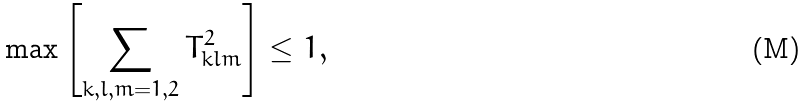Convert formula to latex. <formula><loc_0><loc_0><loc_500><loc_500>\max \left [ \sum _ { k , l , m = 1 , 2 } T _ { k l m } ^ { 2 } \right ] \leq 1 ,</formula> 